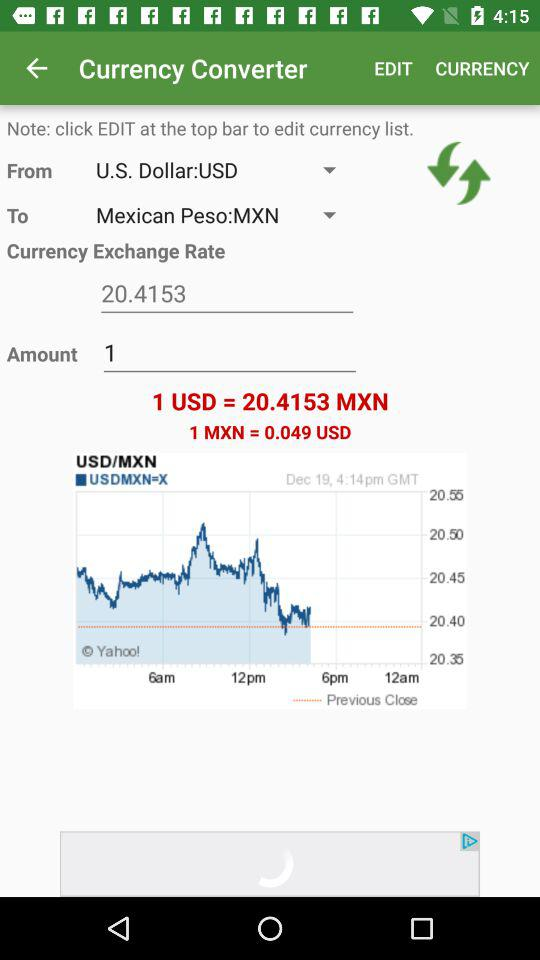Which currency is the US dollar converted into? The US dollar is converted into Mexican Peso. 